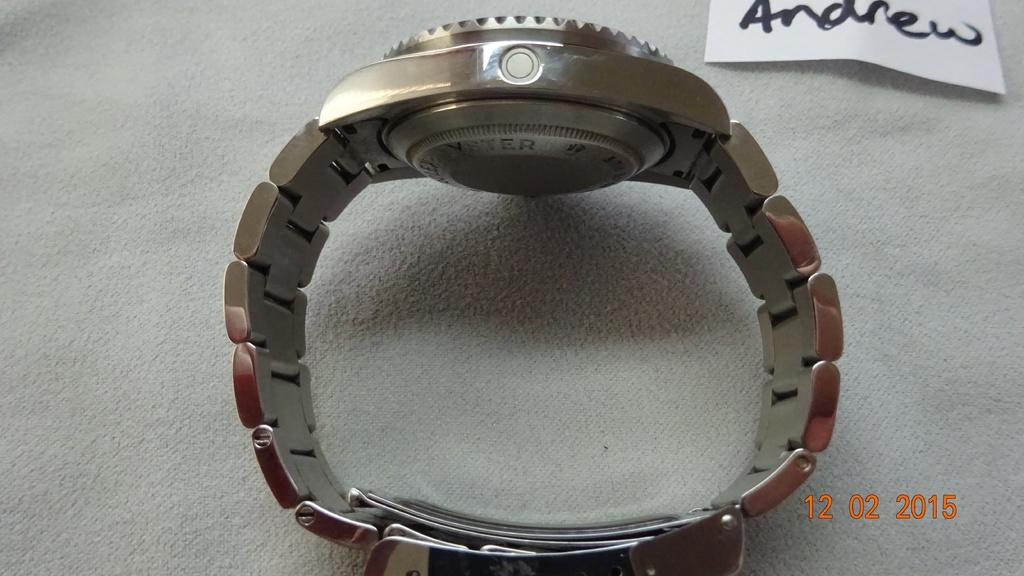<image>
Describe the image concisely. A metallic men's watch laying on its side by a piece of paper with the name Andrew written on it. 